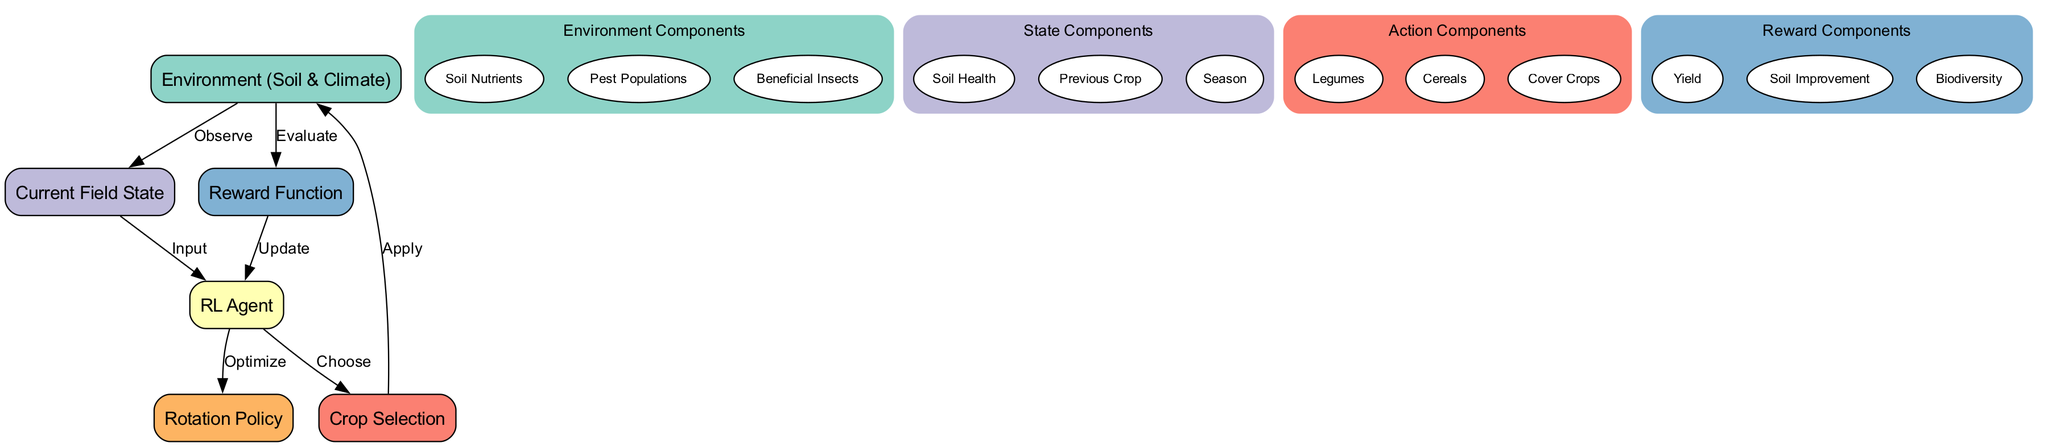What is the main objective of the RL Agent in this diagram? The RL Agent's main objective is to optimize the crop rotation strategy, which is indicated by the connection from the agent to the policy node labeled "Optimize."
Answer: Optimize How many nodes are present in the diagram? The diagram contains six nodes: Environment, RL Agent, Current Field State, Crop Selection, Reward Function, and Rotation Policy.
Answer: Six Which node provides feedback to the agent? The agent receives feedback from the reward node, as indicated by the edges connecting the reward to the agent with the label "Update."
Answer: Reward Function What components are included in the Environment node? The Environment node includes Soil Nutrients, Pest Populations, and Beneficial Insects, which are listed as subnodes within the Environment cluster.
Answer: Soil Nutrients, Pest Populations, Beneficial Insects How does the agent choose an action in the context of the environment? The agent chooses an action based on the current state, shown by the edge labeled "Input" from the Current Field State node to the RL Agent, indicating the information flow for decision-making.
Answer: Current Field State What kind of actions can the RL Agent take? The RL Agent can select among Legumes, Cereals, and Cover Crops, which are specified as possible actions in the action cluster of the diagram.
Answer: Legumes, Cereals, Cover Crops What measures are evaluated to determine the reward in this reinforcement learning setup? The reward is determined based on Yield, Soil Improvement, and Biodiversity, as these factors are specifically listed under the Reward Function cluster in the diagram.
Answer: Yield, Soil Improvement, Biodiversity How does the environment affect the current field state? The environment influences the current field state through observation, as indicated by the directed edge labeled "Observe" pointing from the Environment node to the Current Field State node.
Answer: Observe What is the relationship between the policy and the RL agent? The relationship is that the RL agent optimizes the rotation policy, which is indicated by the edge labeled "Optimize" going from the RL Agent to the Rotation Policy node.
Answer: Optimize 